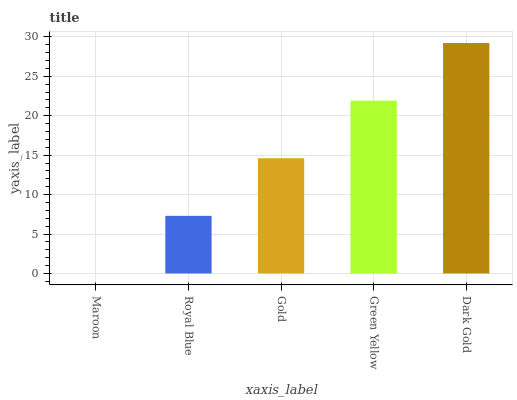Is Maroon the minimum?
Answer yes or no. Yes. Is Dark Gold the maximum?
Answer yes or no. Yes. Is Royal Blue the minimum?
Answer yes or no. No. Is Royal Blue the maximum?
Answer yes or no. No. Is Royal Blue greater than Maroon?
Answer yes or no. Yes. Is Maroon less than Royal Blue?
Answer yes or no. Yes. Is Maroon greater than Royal Blue?
Answer yes or no. No. Is Royal Blue less than Maroon?
Answer yes or no. No. Is Gold the high median?
Answer yes or no. Yes. Is Gold the low median?
Answer yes or no. Yes. Is Maroon the high median?
Answer yes or no. No. Is Royal Blue the low median?
Answer yes or no. No. 